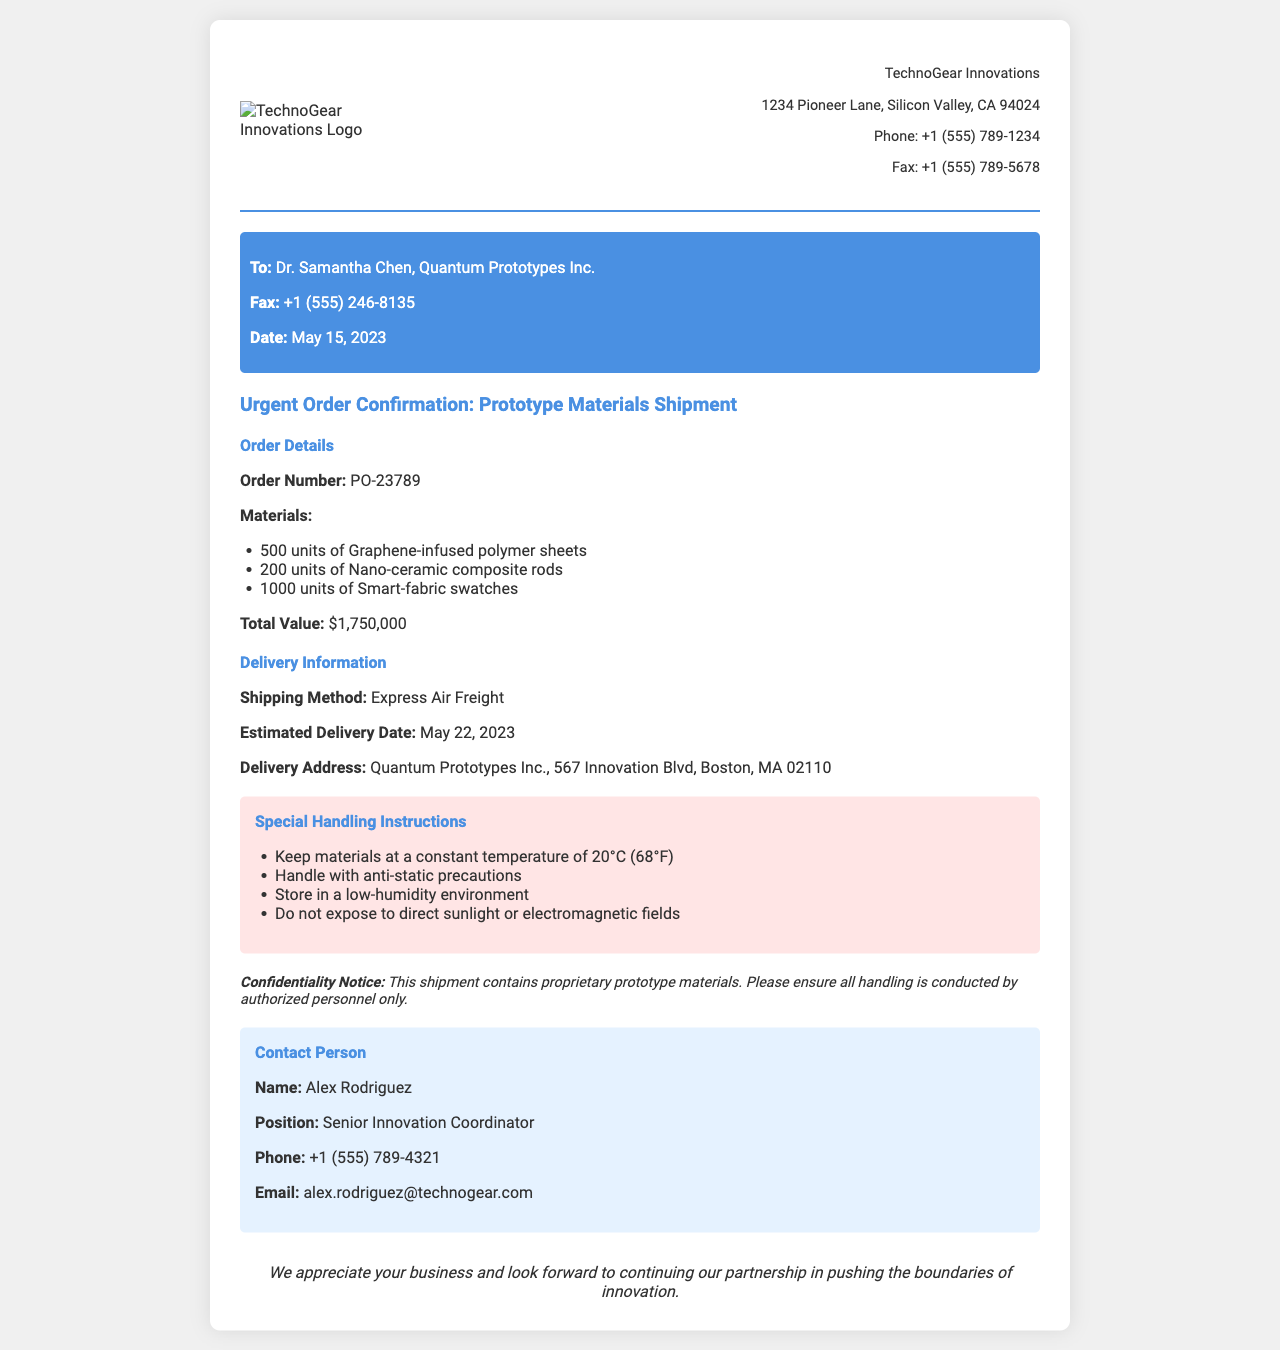What is the order number? The order number is specified in the document as PO-23789.
Answer: PO-23789 Who is the contact person? The document lists Alex Rodriguez as the contact person for this order.
Answer: Alex Rodriguez What is the estimated delivery date? The estimated delivery date provided in the document is May 22, 2023.
Answer: May 22, 2023 How many units of Smart-fabric swatches are included in the order? The document states that there are 1000 units of Smart-fabric swatches in this shipment.
Answer: 1000 units What is the special handling instruction regarding temperature? The document specifies that materials should be kept at a constant temperature of 20°C (68°F).
Answer: 20°C (68°F) What is the total value of the order? The total value listed for the order in the document is $1,750,000.
Answer: $1,750,000 What shipping method is used for delivery? The shipping method mentioned in the document is Express Air Freight.
Answer: Express Air Freight What is the confidentiality notice related to? The confidentiality notice emphasizes that the shipment contains proprietary prototype materials.
Answer: Proprietary prototype materials What is the delivery address? The delivery address provided in the document is Quantum Prototypes Inc., 567 Innovation Blvd, Boston, MA 02110.
Answer: Quantum Prototypes Inc., 567 Innovation Blvd, Boston, MA 02110 